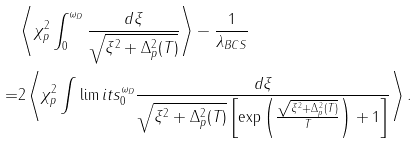<formula> <loc_0><loc_0><loc_500><loc_500>& \left \langle \chi _ { p } ^ { 2 } \int _ { 0 } ^ { \omega _ { D } } \frac { d \xi } { \sqrt { \xi ^ { 2 } + \Delta _ { p } ^ { 2 } ( T ) } } \right \rangle - \frac { 1 } { \lambda _ { B C S } } \\ = & 2 \left \langle \chi _ { p } ^ { 2 } \int \lim i t s _ { 0 } ^ { \omega _ { D } } \frac { d \xi } { \sqrt { \xi ^ { 2 } + \Delta _ { p } ^ { 2 } ( T ) } \left [ \exp \left ( \frac { \sqrt { \xi ^ { 2 } + \Delta _ { p } ^ { 2 } ( T ) } } { T } \right ) + 1 \right ] } \right \rangle .</formula> 